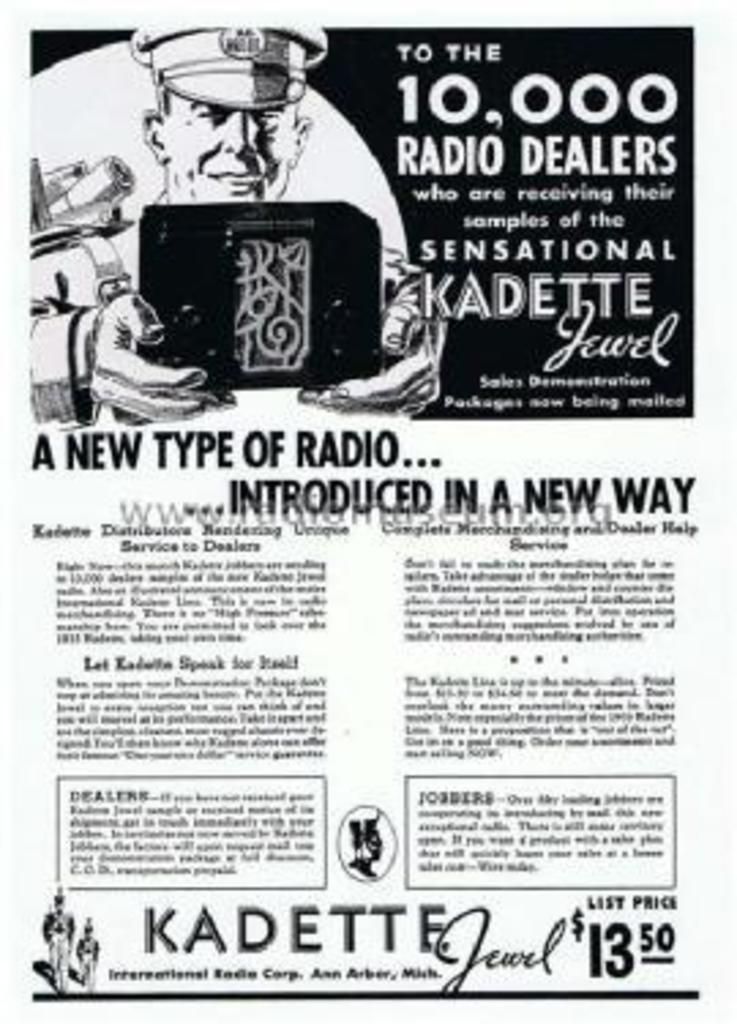<image>
Summarize the visual content of the image. An old advertisement for a new type of radio. 